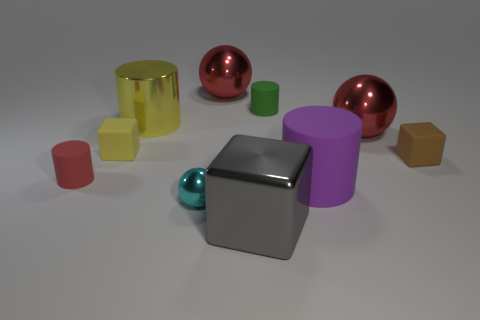Subtract all matte cylinders. How many cylinders are left? 1 Subtract all cubes. How many objects are left? 7 Subtract all purple cylinders. How many cylinders are left? 3 Subtract 1 cubes. How many cubes are left? 2 Subtract all cyan cylinders. Subtract all purple cubes. How many cylinders are left? 4 Subtract all blue cylinders. How many purple spheres are left? 0 Subtract all yellow shiny cylinders. Subtract all small red rubber cylinders. How many objects are left? 8 Add 2 tiny rubber blocks. How many tiny rubber blocks are left? 4 Add 2 tiny green cylinders. How many tiny green cylinders exist? 3 Subtract 1 green cylinders. How many objects are left? 9 